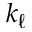Convert formula to latex. <formula><loc_0><loc_0><loc_500><loc_500>k _ { \ell }</formula> 